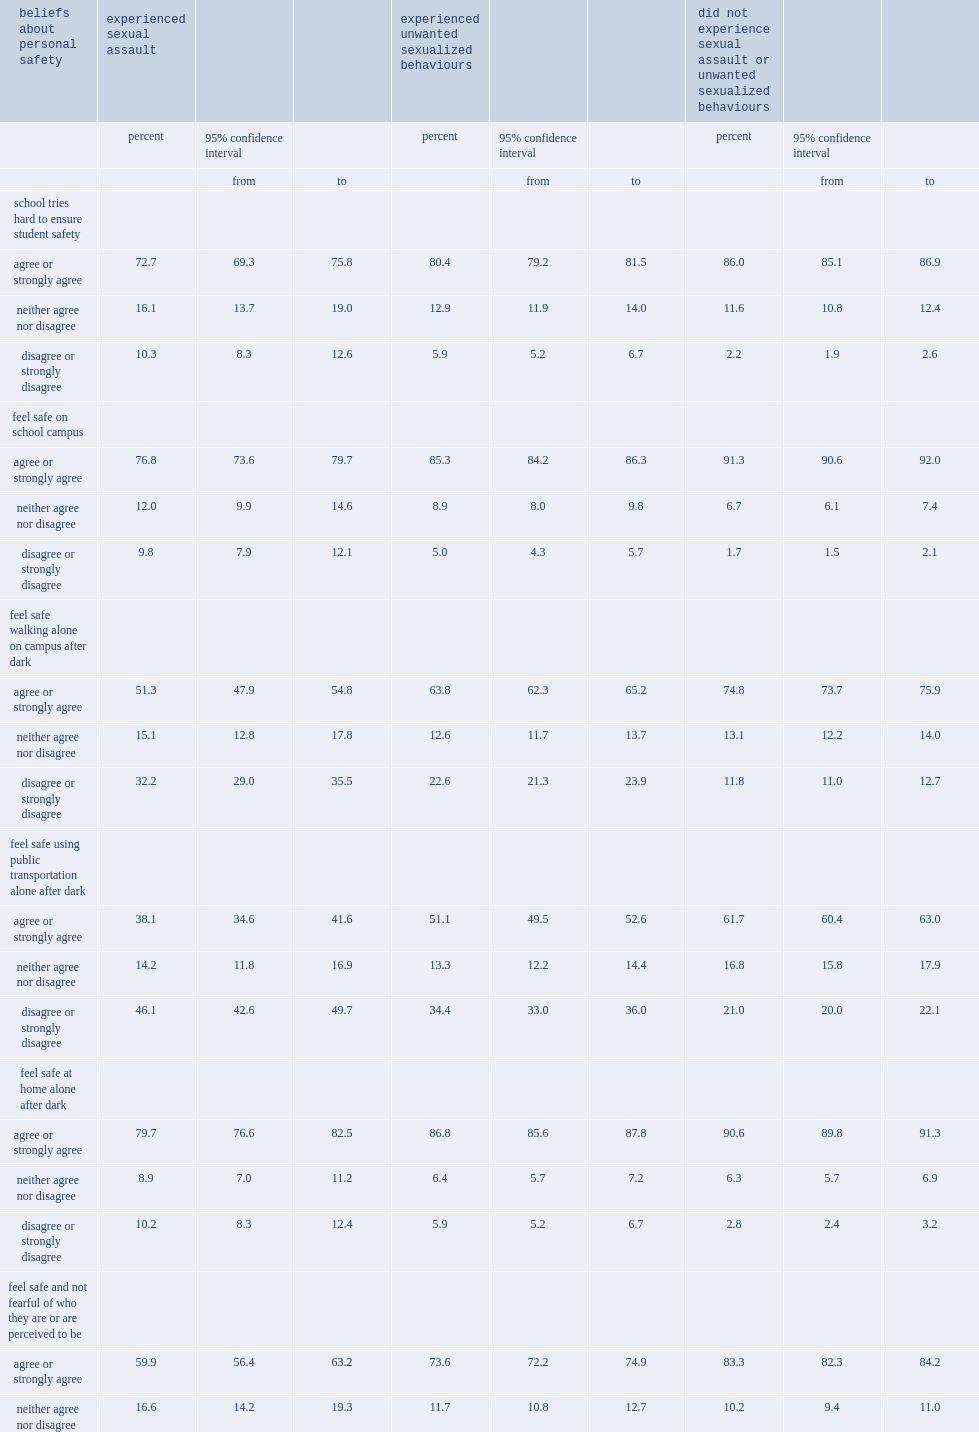How many percent of students who had not experienced any sexual assault or unwanted behaviours agreed or strongly agreed that they felt safe doing so? 61.7. What was the proportion dropped for students who had been sexually assaulted? 38.1. What was the proportion dropped for students who had experienced unwanted sexualized behaviours? 51.1. 